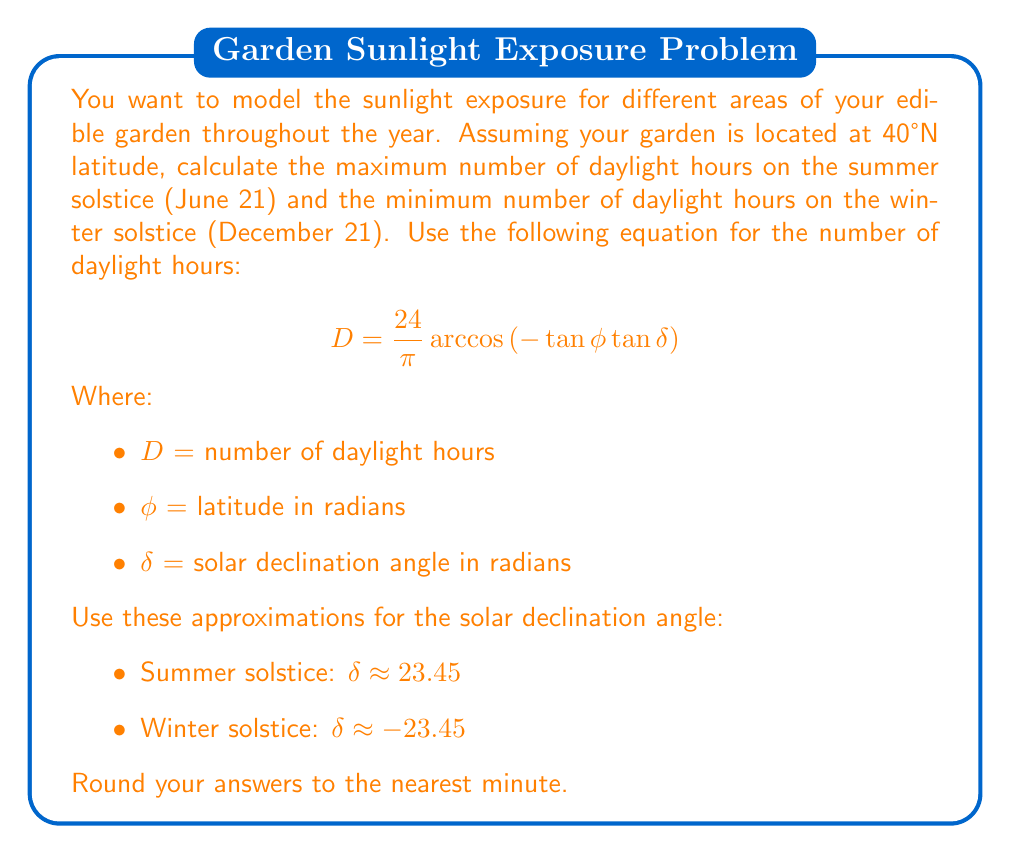Can you answer this question? To solve this problem, we'll follow these steps:

1. Convert the latitude and solar declination angles from degrees to radians.
2. Calculate the number of daylight hours for both the summer and winter solstices.
3. Convert the decimal hours to hours and minutes.

Step 1: Convert angles to radians

Latitude: $\phi = 40° \times \frac{\pi}{180°} = 0.6981$ radians

Summer solstice declination: $\delta_s = 23.45° \times \frac{\pi}{180°} = 0.4093$ radians
Winter solstice declination: $\delta_w = -23.45° \times \frac{\pi}{180°} = -0.4093$ radians

Step 2: Calculate daylight hours

For summer solstice:
$$\begin{align}
D_s &= \frac{24}{\pi} \arccos\left(-\tan(0.6981) \tan(0.4093)\right) \\
&= \frac{24}{\pi} \arccos\left(-0.7673 \times 0.4338\right) \\
&= \frac{24}{\pi} \arccos(0.3329) \\
&= \frac{24}{\pi} \times 1.2317 \\
&= 14.9741 \text{ hours}
\end{align}$$

For winter solstice:
$$\begin{align}
D_w &= \frac{24}{\pi} \arccos\left(-\tan(0.6981) \tan(-0.4093)\right) \\
&= \frac{24}{\pi} \arccos\left(-0.7673 \times (-0.4338)\right) \\
&= \frac{24}{\pi} \arccos(0.3329) \\
&= \frac{24}{\pi} \times 1.2317 \\
&= 9.0259 \text{ hours}
\end{align}$$

Step 3: Convert to hours and minutes

Summer solstice: 14.9741 hours = 14 hours and 58 minutes
Winter solstice: 9.0259 hours = 9 hours and 2 minutes

Rounding to the nearest minute:
Summer solstice: 14 hours and 58 minutes
Winter solstice: 9 hours and 2 minutes
Answer: Summer solstice: 14h 58m, Winter solstice: 9h 2m 